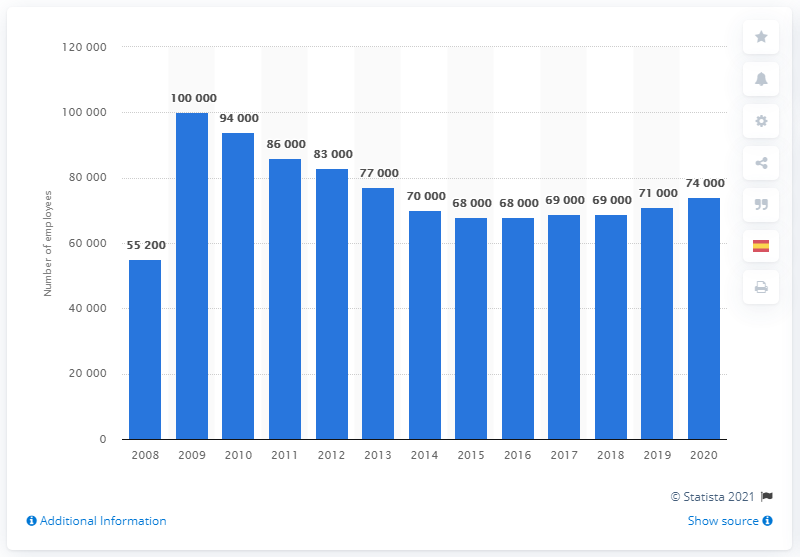Can you tell me more about the trend in employee numbers for Merck & Co. from 2008 to 2020? The bar chart presents a clear trend in the number of employees at Merck & Co. from 2008 to 2020. After reaching a high in 2009 with 100,000 employees, there is a noticeable decline until a low in 2014 of 68,000 employees. Following this period, we observe a gradual increase, with slight fluctuations, reaching 74,000 employees in 2020. 